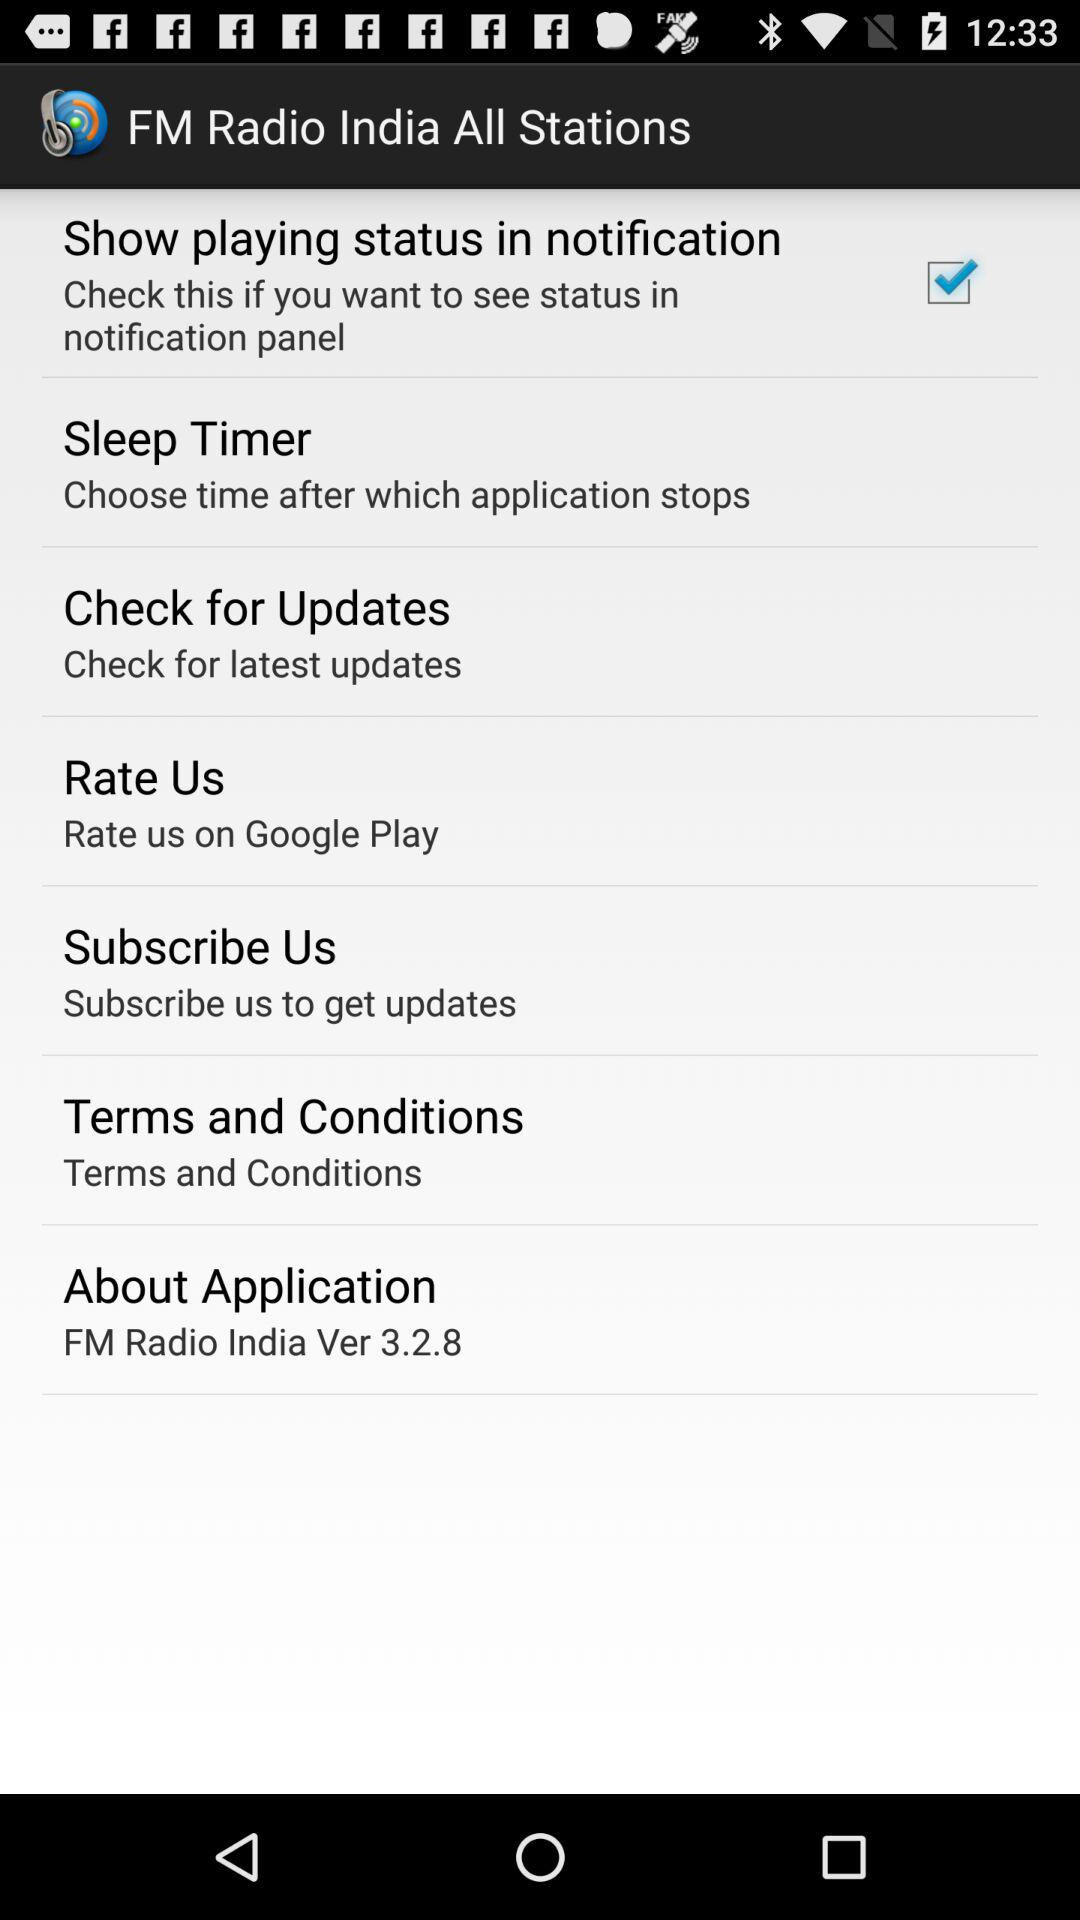Where can I rate this application? You can rate on "Google Play". 